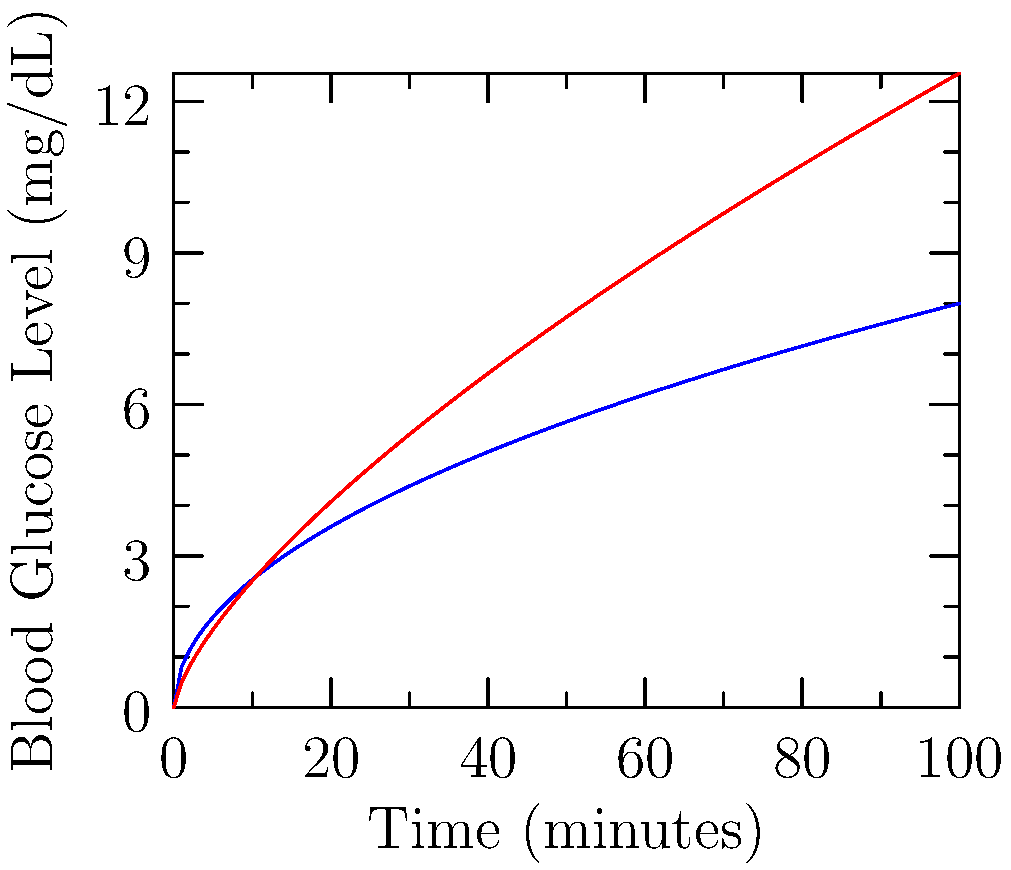The graph shows the blood glucose levels over time for two different food products developed for diabetic individuals. Based on the graph, which product would be more suitable for maintaining stable blood glucose levels, and why? To determine which product is more suitable for maintaining stable blood glucose levels, we need to analyze the rate of glucose absorption for each product:

1. Observe the initial rate of increase:
   - Product A (blue line) shows a steeper initial increase.
   - Product B (red line) has a more gradual initial increase.

2. Compare the overall shape of the curves:
   - Product A's curve rises quickly but then levels off.
   - Product B's curve rises more slowly but continues to increase over time.

3. Analyze the long-term glucose levels:
   - Product A reaches a plateau earlier and maintains a more stable level.
   - Product B continues to rise, potentially leading to higher glucose levels over time.

4. Consider the implications for blood glucose management:
   - A slower, more gradual increase in blood glucose is generally preferred for diabetic individuals.
   - Stable long-term glucose levels are important for avoiding hyperglycemia.

5. Conclusion:
   Product A is more suitable because it provides:
   - A quicker initial rise, which can help prevent hypoglycemia.
   - A more stable long-term glucose level, which is crucial for diabetic individuals.

Product B, while having a slower initial rise, continues to increase glucose levels over time, which could potentially lead to higher blood glucose levels in the long run.
Answer: Product A, due to quicker stabilization and lower long-term glucose levels. 